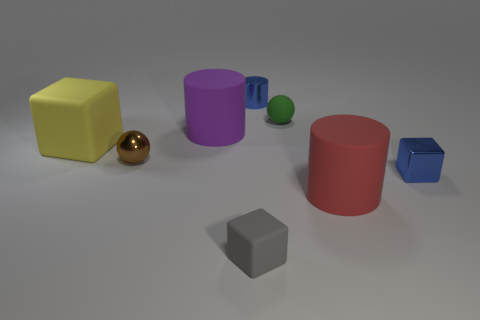What is the shape of the tiny object that is the same color as the shiny block?
Keep it short and to the point. Cylinder. There is a big object to the right of the large purple matte thing; what material is it?
Keep it short and to the point. Rubber. How many things are big rubber things or cubes behind the gray rubber thing?
Your response must be concise. 4. What shape is the brown metallic object that is the same size as the shiny cylinder?
Provide a succinct answer. Sphere. How many metal cylinders have the same color as the tiny shiny cube?
Your answer should be compact. 1. Are the tiny blue thing behind the brown shiny ball and the brown thing made of the same material?
Provide a short and direct response. Yes. What is the shape of the gray matte object?
Make the answer very short. Cube. What number of purple things are small matte cubes or big rubber cylinders?
Keep it short and to the point. 1. What number of other objects are the same material as the gray thing?
Provide a succinct answer. 4. Is the shape of the small matte thing that is behind the small shiny sphere the same as  the red object?
Offer a terse response. No. 